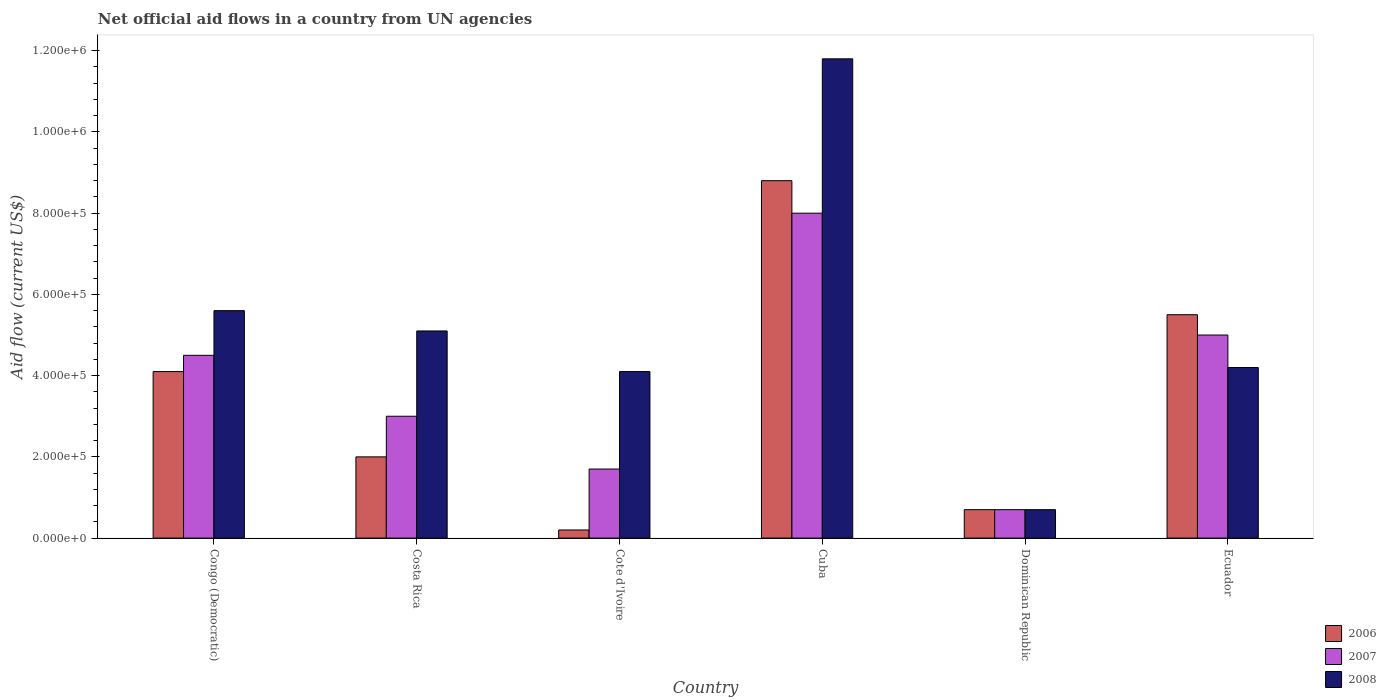Are the number of bars per tick equal to the number of legend labels?
Provide a succinct answer. Yes. How many bars are there on the 5th tick from the left?
Provide a short and direct response. 3. How many bars are there on the 6th tick from the right?
Give a very brief answer. 3. What is the label of the 5th group of bars from the left?
Ensure brevity in your answer.  Dominican Republic. In how many cases, is the number of bars for a given country not equal to the number of legend labels?
Provide a short and direct response. 0. What is the net official aid flow in 2008 in Dominican Republic?
Offer a terse response. 7.00e+04. Across all countries, what is the maximum net official aid flow in 2006?
Keep it short and to the point. 8.80e+05. Across all countries, what is the minimum net official aid flow in 2008?
Make the answer very short. 7.00e+04. In which country was the net official aid flow in 2007 maximum?
Make the answer very short. Cuba. In which country was the net official aid flow in 2008 minimum?
Give a very brief answer. Dominican Republic. What is the total net official aid flow in 2006 in the graph?
Your answer should be very brief. 2.13e+06. What is the difference between the net official aid flow in 2008 in Cuba and that in Ecuador?
Give a very brief answer. 7.60e+05. What is the difference between the net official aid flow in 2006 in Congo (Democratic) and the net official aid flow in 2008 in Cuba?
Your answer should be very brief. -7.70e+05. What is the average net official aid flow in 2007 per country?
Your answer should be very brief. 3.82e+05. What is the difference between the net official aid flow of/in 2008 and net official aid flow of/in 2006 in Cuba?
Offer a terse response. 3.00e+05. In how many countries, is the net official aid flow in 2008 greater than 440000 US$?
Offer a terse response. 3. What is the ratio of the net official aid flow in 2006 in Congo (Democratic) to that in Ecuador?
Your answer should be compact. 0.75. Is the difference between the net official aid flow in 2008 in Congo (Democratic) and Dominican Republic greater than the difference between the net official aid flow in 2006 in Congo (Democratic) and Dominican Republic?
Provide a short and direct response. Yes. What is the difference between the highest and the second highest net official aid flow in 2008?
Your answer should be very brief. 6.70e+05. What is the difference between the highest and the lowest net official aid flow in 2008?
Make the answer very short. 1.11e+06. In how many countries, is the net official aid flow in 2008 greater than the average net official aid flow in 2008 taken over all countries?
Your answer should be compact. 2. What does the 3rd bar from the left in Costa Rica represents?
Your answer should be compact. 2008. How many bars are there?
Make the answer very short. 18. Are the values on the major ticks of Y-axis written in scientific E-notation?
Your answer should be very brief. Yes. Does the graph contain any zero values?
Offer a terse response. No. How are the legend labels stacked?
Give a very brief answer. Vertical. What is the title of the graph?
Your answer should be very brief. Net official aid flows in a country from UN agencies. What is the label or title of the X-axis?
Give a very brief answer. Country. What is the label or title of the Y-axis?
Ensure brevity in your answer.  Aid flow (current US$). What is the Aid flow (current US$) of 2007 in Congo (Democratic)?
Your answer should be compact. 4.50e+05. What is the Aid flow (current US$) of 2008 in Congo (Democratic)?
Provide a short and direct response. 5.60e+05. What is the Aid flow (current US$) in 2006 in Costa Rica?
Provide a succinct answer. 2.00e+05. What is the Aid flow (current US$) of 2008 in Costa Rica?
Offer a very short reply. 5.10e+05. What is the Aid flow (current US$) in 2006 in Cote d'Ivoire?
Make the answer very short. 2.00e+04. What is the Aid flow (current US$) in 2007 in Cote d'Ivoire?
Provide a succinct answer. 1.70e+05. What is the Aid flow (current US$) of 2006 in Cuba?
Give a very brief answer. 8.80e+05. What is the Aid flow (current US$) in 2008 in Cuba?
Provide a succinct answer. 1.18e+06. What is the Aid flow (current US$) of 2006 in Dominican Republic?
Ensure brevity in your answer.  7.00e+04. What is the Aid flow (current US$) of 2008 in Dominican Republic?
Provide a succinct answer. 7.00e+04. What is the Aid flow (current US$) of 2006 in Ecuador?
Your answer should be compact. 5.50e+05. Across all countries, what is the maximum Aid flow (current US$) in 2006?
Give a very brief answer. 8.80e+05. Across all countries, what is the maximum Aid flow (current US$) of 2007?
Offer a very short reply. 8.00e+05. Across all countries, what is the maximum Aid flow (current US$) of 2008?
Offer a terse response. 1.18e+06. Across all countries, what is the minimum Aid flow (current US$) of 2006?
Keep it short and to the point. 2.00e+04. Across all countries, what is the minimum Aid flow (current US$) in 2007?
Ensure brevity in your answer.  7.00e+04. What is the total Aid flow (current US$) in 2006 in the graph?
Keep it short and to the point. 2.13e+06. What is the total Aid flow (current US$) in 2007 in the graph?
Make the answer very short. 2.29e+06. What is the total Aid flow (current US$) of 2008 in the graph?
Your answer should be compact. 3.15e+06. What is the difference between the Aid flow (current US$) of 2006 in Congo (Democratic) and that in Costa Rica?
Provide a succinct answer. 2.10e+05. What is the difference between the Aid flow (current US$) of 2008 in Congo (Democratic) and that in Costa Rica?
Provide a short and direct response. 5.00e+04. What is the difference between the Aid flow (current US$) of 2007 in Congo (Democratic) and that in Cote d'Ivoire?
Your answer should be compact. 2.80e+05. What is the difference between the Aid flow (current US$) in 2006 in Congo (Democratic) and that in Cuba?
Keep it short and to the point. -4.70e+05. What is the difference between the Aid flow (current US$) in 2007 in Congo (Democratic) and that in Cuba?
Your answer should be very brief. -3.50e+05. What is the difference between the Aid flow (current US$) of 2008 in Congo (Democratic) and that in Cuba?
Your answer should be very brief. -6.20e+05. What is the difference between the Aid flow (current US$) of 2006 in Congo (Democratic) and that in Dominican Republic?
Provide a succinct answer. 3.40e+05. What is the difference between the Aid flow (current US$) of 2007 in Congo (Democratic) and that in Dominican Republic?
Give a very brief answer. 3.80e+05. What is the difference between the Aid flow (current US$) in 2008 in Congo (Democratic) and that in Dominican Republic?
Provide a short and direct response. 4.90e+05. What is the difference between the Aid flow (current US$) of 2006 in Congo (Democratic) and that in Ecuador?
Offer a very short reply. -1.40e+05. What is the difference between the Aid flow (current US$) in 2007 in Congo (Democratic) and that in Ecuador?
Provide a succinct answer. -5.00e+04. What is the difference between the Aid flow (current US$) in 2008 in Congo (Democratic) and that in Ecuador?
Give a very brief answer. 1.40e+05. What is the difference between the Aid flow (current US$) of 2006 in Costa Rica and that in Cote d'Ivoire?
Provide a succinct answer. 1.80e+05. What is the difference between the Aid flow (current US$) in 2007 in Costa Rica and that in Cote d'Ivoire?
Ensure brevity in your answer.  1.30e+05. What is the difference between the Aid flow (current US$) of 2006 in Costa Rica and that in Cuba?
Your answer should be compact. -6.80e+05. What is the difference between the Aid flow (current US$) of 2007 in Costa Rica and that in Cuba?
Your answer should be very brief. -5.00e+05. What is the difference between the Aid flow (current US$) in 2008 in Costa Rica and that in Cuba?
Provide a succinct answer. -6.70e+05. What is the difference between the Aid flow (current US$) in 2006 in Costa Rica and that in Dominican Republic?
Offer a terse response. 1.30e+05. What is the difference between the Aid flow (current US$) in 2007 in Costa Rica and that in Dominican Republic?
Provide a succinct answer. 2.30e+05. What is the difference between the Aid flow (current US$) of 2008 in Costa Rica and that in Dominican Republic?
Your response must be concise. 4.40e+05. What is the difference between the Aid flow (current US$) of 2006 in Costa Rica and that in Ecuador?
Provide a succinct answer. -3.50e+05. What is the difference between the Aid flow (current US$) in 2007 in Costa Rica and that in Ecuador?
Provide a short and direct response. -2.00e+05. What is the difference between the Aid flow (current US$) of 2008 in Costa Rica and that in Ecuador?
Your response must be concise. 9.00e+04. What is the difference between the Aid flow (current US$) in 2006 in Cote d'Ivoire and that in Cuba?
Offer a terse response. -8.60e+05. What is the difference between the Aid flow (current US$) in 2007 in Cote d'Ivoire and that in Cuba?
Make the answer very short. -6.30e+05. What is the difference between the Aid flow (current US$) in 2008 in Cote d'Ivoire and that in Cuba?
Ensure brevity in your answer.  -7.70e+05. What is the difference between the Aid flow (current US$) in 2006 in Cote d'Ivoire and that in Dominican Republic?
Your response must be concise. -5.00e+04. What is the difference between the Aid flow (current US$) in 2007 in Cote d'Ivoire and that in Dominican Republic?
Offer a very short reply. 1.00e+05. What is the difference between the Aid flow (current US$) in 2008 in Cote d'Ivoire and that in Dominican Republic?
Your answer should be very brief. 3.40e+05. What is the difference between the Aid flow (current US$) in 2006 in Cote d'Ivoire and that in Ecuador?
Provide a short and direct response. -5.30e+05. What is the difference between the Aid flow (current US$) of 2007 in Cote d'Ivoire and that in Ecuador?
Make the answer very short. -3.30e+05. What is the difference between the Aid flow (current US$) in 2008 in Cote d'Ivoire and that in Ecuador?
Offer a terse response. -10000. What is the difference between the Aid flow (current US$) of 2006 in Cuba and that in Dominican Republic?
Provide a succinct answer. 8.10e+05. What is the difference between the Aid flow (current US$) of 2007 in Cuba and that in Dominican Republic?
Your answer should be compact. 7.30e+05. What is the difference between the Aid flow (current US$) of 2008 in Cuba and that in Dominican Republic?
Your answer should be compact. 1.11e+06. What is the difference between the Aid flow (current US$) of 2006 in Cuba and that in Ecuador?
Your response must be concise. 3.30e+05. What is the difference between the Aid flow (current US$) of 2007 in Cuba and that in Ecuador?
Offer a very short reply. 3.00e+05. What is the difference between the Aid flow (current US$) of 2008 in Cuba and that in Ecuador?
Make the answer very short. 7.60e+05. What is the difference between the Aid flow (current US$) of 2006 in Dominican Republic and that in Ecuador?
Make the answer very short. -4.80e+05. What is the difference between the Aid flow (current US$) in 2007 in Dominican Republic and that in Ecuador?
Your answer should be compact. -4.30e+05. What is the difference between the Aid flow (current US$) in 2008 in Dominican Republic and that in Ecuador?
Give a very brief answer. -3.50e+05. What is the difference between the Aid flow (current US$) in 2006 in Congo (Democratic) and the Aid flow (current US$) in 2007 in Costa Rica?
Your response must be concise. 1.10e+05. What is the difference between the Aid flow (current US$) of 2006 in Congo (Democratic) and the Aid flow (current US$) of 2008 in Costa Rica?
Make the answer very short. -1.00e+05. What is the difference between the Aid flow (current US$) in 2006 in Congo (Democratic) and the Aid flow (current US$) in 2008 in Cote d'Ivoire?
Offer a very short reply. 0. What is the difference between the Aid flow (current US$) in 2006 in Congo (Democratic) and the Aid flow (current US$) in 2007 in Cuba?
Keep it short and to the point. -3.90e+05. What is the difference between the Aid flow (current US$) of 2006 in Congo (Democratic) and the Aid flow (current US$) of 2008 in Cuba?
Keep it short and to the point. -7.70e+05. What is the difference between the Aid flow (current US$) in 2007 in Congo (Democratic) and the Aid flow (current US$) in 2008 in Cuba?
Provide a short and direct response. -7.30e+05. What is the difference between the Aid flow (current US$) in 2006 in Congo (Democratic) and the Aid flow (current US$) in 2007 in Dominican Republic?
Your response must be concise. 3.40e+05. What is the difference between the Aid flow (current US$) in 2006 in Congo (Democratic) and the Aid flow (current US$) in 2008 in Dominican Republic?
Offer a terse response. 3.40e+05. What is the difference between the Aid flow (current US$) in 2007 in Congo (Democratic) and the Aid flow (current US$) in 2008 in Ecuador?
Your response must be concise. 3.00e+04. What is the difference between the Aid flow (current US$) of 2006 in Costa Rica and the Aid flow (current US$) of 2007 in Cote d'Ivoire?
Offer a very short reply. 3.00e+04. What is the difference between the Aid flow (current US$) of 2007 in Costa Rica and the Aid flow (current US$) of 2008 in Cote d'Ivoire?
Ensure brevity in your answer.  -1.10e+05. What is the difference between the Aid flow (current US$) of 2006 in Costa Rica and the Aid flow (current US$) of 2007 in Cuba?
Your response must be concise. -6.00e+05. What is the difference between the Aid flow (current US$) in 2006 in Costa Rica and the Aid flow (current US$) in 2008 in Cuba?
Your answer should be compact. -9.80e+05. What is the difference between the Aid flow (current US$) in 2007 in Costa Rica and the Aid flow (current US$) in 2008 in Cuba?
Your answer should be very brief. -8.80e+05. What is the difference between the Aid flow (current US$) of 2006 in Costa Rica and the Aid flow (current US$) of 2008 in Dominican Republic?
Give a very brief answer. 1.30e+05. What is the difference between the Aid flow (current US$) of 2006 in Costa Rica and the Aid flow (current US$) of 2008 in Ecuador?
Your answer should be very brief. -2.20e+05. What is the difference between the Aid flow (current US$) in 2007 in Costa Rica and the Aid flow (current US$) in 2008 in Ecuador?
Make the answer very short. -1.20e+05. What is the difference between the Aid flow (current US$) of 2006 in Cote d'Ivoire and the Aid flow (current US$) of 2007 in Cuba?
Provide a succinct answer. -7.80e+05. What is the difference between the Aid flow (current US$) in 2006 in Cote d'Ivoire and the Aid flow (current US$) in 2008 in Cuba?
Ensure brevity in your answer.  -1.16e+06. What is the difference between the Aid flow (current US$) of 2007 in Cote d'Ivoire and the Aid flow (current US$) of 2008 in Cuba?
Provide a short and direct response. -1.01e+06. What is the difference between the Aid flow (current US$) in 2006 in Cote d'Ivoire and the Aid flow (current US$) in 2007 in Dominican Republic?
Give a very brief answer. -5.00e+04. What is the difference between the Aid flow (current US$) of 2006 in Cote d'Ivoire and the Aid flow (current US$) of 2008 in Dominican Republic?
Provide a succinct answer. -5.00e+04. What is the difference between the Aid flow (current US$) of 2006 in Cote d'Ivoire and the Aid flow (current US$) of 2007 in Ecuador?
Make the answer very short. -4.80e+05. What is the difference between the Aid flow (current US$) in 2006 in Cote d'Ivoire and the Aid flow (current US$) in 2008 in Ecuador?
Provide a short and direct response. -4.00e+05. What is the difference between the Aid flow (current US$) in 2007 in Cote d'Ivoire and the Aid flow (current US$) in 2008 in Ecuador?
Make the answer very short. -2.50e+05. What is the difference between the Aid flow (current US$) in 2006 in Cuba and the Aid flow (current US$) in 2007 in Dominican Republic?
Your answer should be very brief. 8.10e+05. What is the difference between the Aid flow (current US$) in 2006 in Cuba and the Aid flow (current US$) in 2008 in Dominican Republic?
Offer a terse response. 8.10e+05. What is the difference between the Aid flow (current US$) in 2007 in Cuba and the Aid flow (current US$) in 2008 in Dominican Republic?
Provide a short and direct response. 7.30e+05. What is the difference between the Aid flow (current US$) in 2006 in Cuba and the Aid flow (current US$) in 2008 in Ecuador?
Provide a succinct answer. 4.60e+05. What is the difference between the Aid flow (current US$) of 2006 in Dominican Republic and the Aid flow (current US$) of 2007 in Ecuador?
Your answer should be very brief. -4.30e+05. What is the difference between the Aid flow (current US$) of 2006 in Dominican Republic and the Aid flow (current US$) of 2008 in Ecuador?
Your answer should be very brief. -3.50e+05. What is the difference between the Aid flow (current US$) of 2007 in Dominican Republic and the Aid flow (current US$) of 2008 in Ecuador?
Offer a terse response. -3.50e+05. What is the average Aid flow (current US$) in 2006 per country?
Your answer should be very brief. 3.55e+05. What is the average Aid flow (current US$) of 2007 per country?
Ensure brevity in your answer.  3.82e+05. What is the average Aid flow (current US$) in 2008 per country?
Provide a succinct answer. 5.25e+05. What is the difference between the Aid flow (current US$) of 2006 and Aid flow (current US$) of 2007 in Congo (Democratic)?
Ensure brevity in your answer.  -4.00e+04. What is the difference between the Aid flow (current US$) of 2006 and Aid flow (current US$) of 2008 in Congo (Democratic)?
Give a very brief answer. -1.50e+05. What is the difference between the Aid flow (current US$) in 2007 and Aid flow (current US$) in 2008 in Congo (Democratic)?
Ensure brevity in your answer.  -1.10e+05. What is the difference between the Aid flow (current US$) in 2006 and Aid flow (current US$) in 2008 in Costa Rica?
Your answer should be very brief. -3.10e+05. What is the difference between the Aid flow (current US$) in 2006 and Aid flow (current US$) in 2008 in Cote d'Ivoire?
Keep it short and to the point. -3.90e+05. What is the difference between the Aid flow (current US$) in 2007 and Aid flow (current US$) in 2008 in Cote d'Ivoire?
Your answer should be very brief. -2.40e+05. What is the difference between the Aid flow (current US$) of 2006 and Aid flow (current US$) of 2008 in Cuba?
Ensure brevity in your answer.  -3.00e+05. What is the difference between the Aid flow (current US$) of 2007 and Aid flow (current US$) of 2008 in Cuba?
Your response must be concise. -3.80e+05. What is the difference between the Aid flow (current US$) of 2006 and Aid flow (current US$) of 2008 in Dominican Republic?
Your response must be concise. 0. What is the difference between the Aid flow (current US$) of 2007 and Aid flow (current US$) of 2008 in Dominican Republic?
Your answer should be very brief. 0. What is the ratio of the Aid flow (current US$) of 2006 in Congo (Democratic) to that in Costa Rica?
Your response must be concise. 2.05. What is the ratio of the Aid flow (current US$) of 2008 in Congo (Democratic) to that in Costa Rica?
Give a very brief answer. 1.1. What is the ratio of the Aid flow (current US$) of 2006 in Congo (Democratic) to that in Cote d'Ivoire?
Offer a terse response. 20.5. What is the ratio of the Aid flow (current US$) in 2007 in Congo (Democratic) to that in Cote d'Ivoire?
Ensure brevity in your answer.  2.65. What is the ratio of the Aid flow (current US$) of 2008 in Congo (Democratic) to that in Cote d'Ivoire?
Offer a terse response. 1.37. What is the ratio of the Aid flow (current US$) in 2006 in Congo (Democratic) to that in Cuba?
Your answer should be compact. 0.47. What is the ratio of the Aid flow (current US$) of 2007 in Congo (Democratic) to that in Cuba?
Give a very brief answer. 0.56. What is the ratio of the Aid flow (current US$) of 2008 in Congo (Democratic) to that in Cuba?
Provide a succinct answer. 0.47. What is the ratio of the Aid flow (current US$) in 2006 in Congo (Democratic) to that in Dominican Republic?
Give a very brief answer. 5.86. What is the ratio of the Aid flow (current US$) of 2007 in Congo (Democratic) to that in Dominican Republic?
Offer a terse response. 6.43. What is the ratio of the Aid flow (current US$) of 2008 in Congo (Democratic) to that in Dominican Republic?
Provide a short and direct response. 8. What is the ratio of the Aid flow (current US$) of 2006 in Congo (Democratic) to that in Ecuador?
Your answer should be very brief. 0.75. What is the ratio of the Aid flow (current US$) in 2006 in Costa Rica to that in Cote d'Ivoire?
Give a very brief answer. 10. What is the ratio of the Aid flow (current US$) in 2007 in Costa Rica to that in Cote d'Ivoire?
Provide a short and direct response. 1.76. What is the ratio of the Aid flow (current US$) in 2008 in Costa Rica to that in Cote d'Ivoire?
Provide a succinct answer. 1.24. What is the ratio of the Aid flow (current US$) of 2006 in Costa Rica to that in Cuba?
Offer a terse response. 0.23. What is the ratio of the Aid flow (current US$) of 2008 in Costa Rica to that in Cuba?
Keep it short and to the point. 0.43. What is the ratio of the Aid flow (current US$) of 2006 in Costa Rica to that in Dominican Republic?
Offer a terse response. 2.86. What is the ratio of the Aid flow (current US$) of 2007 in Costa Rica to that in Dominican Republic?
Ensure brevity in your answer.  4.29. What is the ratio of the Aid flow (current US$) of 2008 in Costa Rica to that in Dominican Republic?
Keep it short and to the point. 7.29. What is the ratio of the Aid flow (current US$) of 2006 in Costa Rica to that in Ecuador?
Your answer should be very brief. 0.36. What is the ratio of the Aid flow (current US$) in 2007 in Costa Rica to that in Ecuador?
Provide a short and direct response. 0.6. What is the ratio of the Aid flow (current US$) of 2008 in Costa Rica to that in Ecuador?
Provide a succinct answer. 1.21. What is the ratio of the Aid flow (current US$) in 2006 in Cote d'Ivoire to that in Cuba?
Your answer should be very brief. 0.02. What is the ratio of the Aid flow (current US$) in 2007 in Cote d'Ivoire to that in Cuba?
Give a very brief answer. 0.21. What is the ratio of the Aid flow (current US$) of 2008 in Cote d'Ivoire to that in Cuba?
Offer a very short reply. 0.35. What is the ratio of the Aid flow (current US$) of 2006 in Cote d'Ivoire to that in Dominican Republic?
Offer a terse response. 0.29. What is the ratio of the Aid flow (current US$) of 2007 in Cote d'Ivoire to that in Dominican Republic?
Ensure brevity in your answer.  2.43. What is the ratio of the Aid flow (current US$) of 2008 in Cote d'Ivoire to that in Dominican Republic?
Provide a succinct answer. 5.86. What is the ratio of the Aid flow (current US$) of 2006 in Cote d'Ivoire to that in Ecuador?
Your answer should be very brief. 0.04. What is the ratio of the Aid flow (current US$) in 2007 in Cote d'Ivoire to that in Ecuador?
Give a very brief answer. 0.34. What is the ratio of the Aid flow (current US$) of 2008 in Cote d'Ivoire to that in Ecuador?
Offer a very short reply. 0.98. What is the ratio of the Aid flow (current US$) in 2006 in Cuba to that in Dominican Republic?
Keep it short and to the point. 12.57. What is the ratio of the Aid flow (current US$) of 2007 in Cuba to that in Dominican Republic?
Keep it short and to the point. 11.43. What is the ratio of the Aid flow (current US$) in 2008 in Cuba to that in Dominican Republic?
Make the answer very short. 16.86. What is the ratio of the Aid flow (current US$) of 2008 in Cuba to that in Ecuador?
Give a very brief answer. 2.81. What is the ratio of the Aid flow (current US$) in 2006 in Dominican Republic to that in Ecuador?
Provide a short and direct response. 0.13. What is the ratio of the Aid flow (current US$) of 2007 in Dominican Republic to that in Ecuador?
Provide a succinct answer. 0.14. What is the difference between the highest and the second highest Aid flow (current US$) in 2007?
Your answer should be very brief. 3.00e+05. What is the difference between the highest and the second highest Aid flow (current US$) in 2008?
Your answer should be very brief. 6.20e+05. What is the difference between the highest and the lowest Aid flow (current US$) in 2006?
Offer a very short reply. 8.60e+05. What is the difference between the highest and the lowest Aid flow (current US$) of 2007?
Ensure brevity in your answer.  7.30e+05. What is the difference between the highest and the lowest Aid flow (current US$) of 2008?
Ensure brevity in your answer.  1.11e+06. 